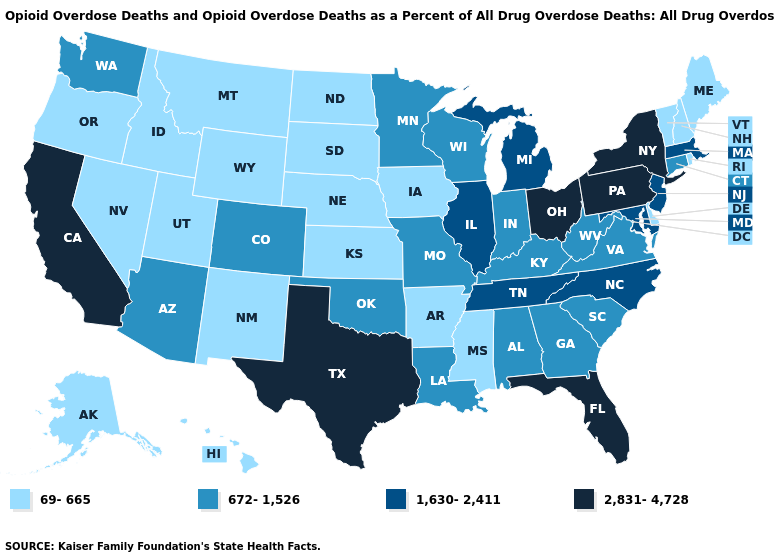Does Michigan have a higher value than Wisconsin?
Quick response, please. Yes. Which states have the highest value in the USA?
Give a very brief answer. California, Florida, New York, Ohio, Pennsylvania, Texas. Name the states that have a value in the range 672-1,526?
Answer briefly. Alabama, Arizona, Colorado, Connecticut, Georgia, Indiana, Kentucky, Louisiana, Minnesota, Missouri, Oklahoma, South Carolina, Virginia, Washington, West Virginia, Wisconsin. Which states have the highest value in the USA?
Keep it brief. California, Florida, New York, Ohio, Pennsylvania, Texas. Does West Virginia have a higher value than Oregon?
Write a very short answer. Yes. Does California have the highest value in the West?
Write a very short answer. Yes. Does Connecticut have a higher value than Arkansas?
Write a very short answer. Yes. Name the states that have a value in the range 1,630-2,411?
Quick response, please. Illinois, Maryland, Massachusetts, Michigan, New Jersey, North Carolina, Tennessee. What is the value of Virginia?
Answer briefly. 672-1,526. How many symbols are there in the legend?
Keep it brief. 4. How many symbols are there in the legend?
Short answer required. 4. What is the value of Rhode Island?
Be succinct. 69-665. What is the highest value in the USA?
Keep it brief. 2,831-4,728. What is the value of Utah?
Keep it brief. 69-665. Does Maine have the lowest value in the USA?
Concise answer only. Yes. 